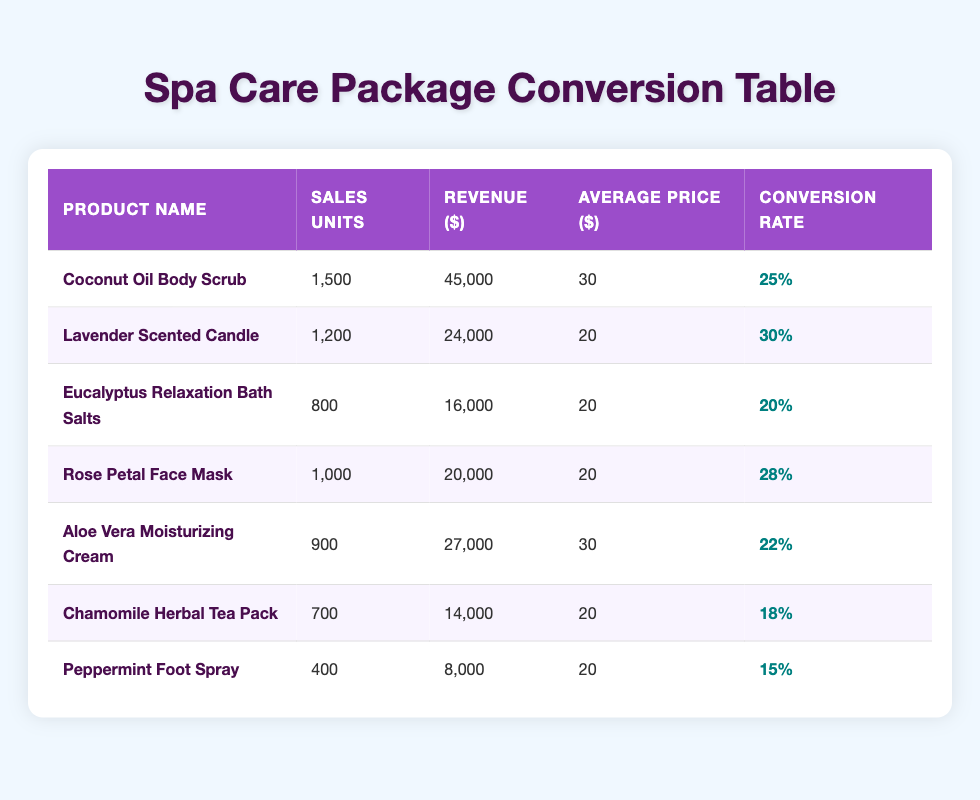What is the product with the highest sales units? By looking at the "Sales Units" column, the product with the highest sales is "Coconut Oil Body Scrub" with 1500 units sold.
Answer: Coconut Oil Body Scrub What is the total revenue generated by all products combined? To find the total revenue, add up the revenue of each product: 45000 + 24000 + 16000 + 20000 + 27000 + 14000 + 8000 = 107000.
Answer: 107000 Which product has the lowest conversion rate? The conversion rates of the products are as follows: 25%, 30%, 20%, 28%, 22%, 18%, and 15%. The lowest rate is 15% for "Peppermint Foot Spray."
Answer: Peppermint Foot Spray What is the average sales unit of all products? To calculate the average, sum the sales units: 1500 + 1200 + 800 + 1000 + 900 + 700 + 400 = 5100. Then divide by the number of products, which is 7: 5100 / 7 = 728.57.
Answer: 728.57 Did "Lavender Scented Candle" generate more revenue than "Eucalyptus Relaxation Bath Salts"? The revenue for "Lavender Scented Candle" is 24000, while for "Eucalyptus Relaxation Bath Salts," it is 16000. Since 24000 is greater than 16000, the statement is true.
Answer: Yes Which product had sales units between 700 and 1000? Looking at the "Sales Units" column, "Rose Petal Face Mask" with 1000 units and "Chamomile Herbal Tea Pack" with 700 units are within that range.
Answer: Rose Petal Face Mask, Chamomile Herbal Tea Pack What is the difference in revenue between the top-selling product and the one with the second highest sales? The top-selling product "Coconut Oil Body Scrub" has a revenue of 45000, and the second highest "Lavender Scented Candle" has 24000. The difference is 45000 - 24000 = 21000.
Answer: 21000 Is the average price of "Aloe Vera Moisturizing Cream" higher than the average price of "Chamomile Herbal Tea Pack"? Both products have an average price of 30 and 20 respectively, making Aloe Vera more expensive. Hence, the answer is true.
Answer: Yes What percentage of total sales units does "Eucalyptus Relaxation Bath Salts" represent? The sales units of "Eucalyptus Relaxation Bath Salts" are 800. The total units are 5100. The percentage is (800 / 5100) * 100 = 15.69%.
Answer: 15.69% 